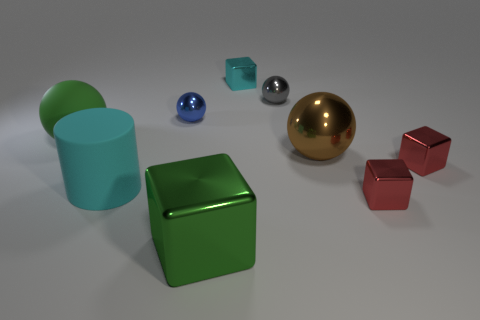How many red blocks must be subtracted to get 1 red blocks? 1 Subtract all yellow blocks. Subtract all brown cylinders. How many blocks are left? 4 Add 1 cyan metal cubes. How many objects exist? 10 Subtract all blocks. How many objects are left? 5 Add 9 cyan cubes. How many cyan cubes are left? 10 Add 6 small matte spheres. How many small matte spheres exist? 6 Subtract 0 red spheres. How many objects are left? 9 Subtract all green blocks. Subtract all blue spheres. How many objects are left? 7 